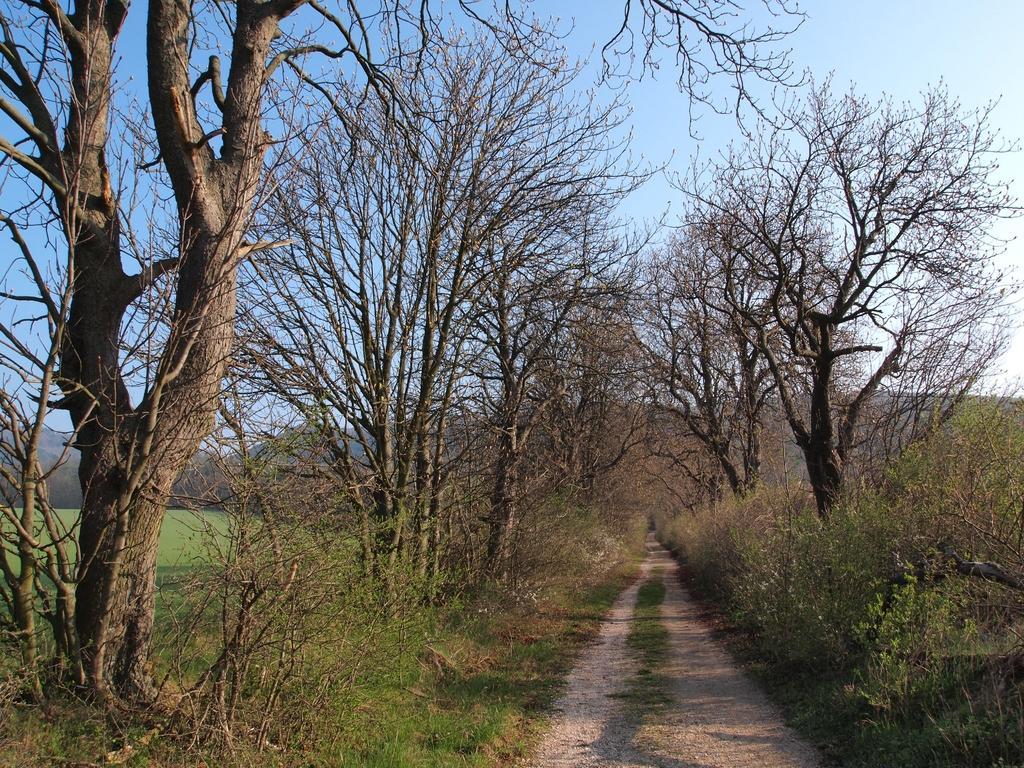Could you give a brief overview of what you see in this image? In this image I can see a path in the centre and on the both sides of the path I can see grass, bushes and number of trees. On the left side of the image I can see an open grass ground. In the background I can see mountains and the sky. 